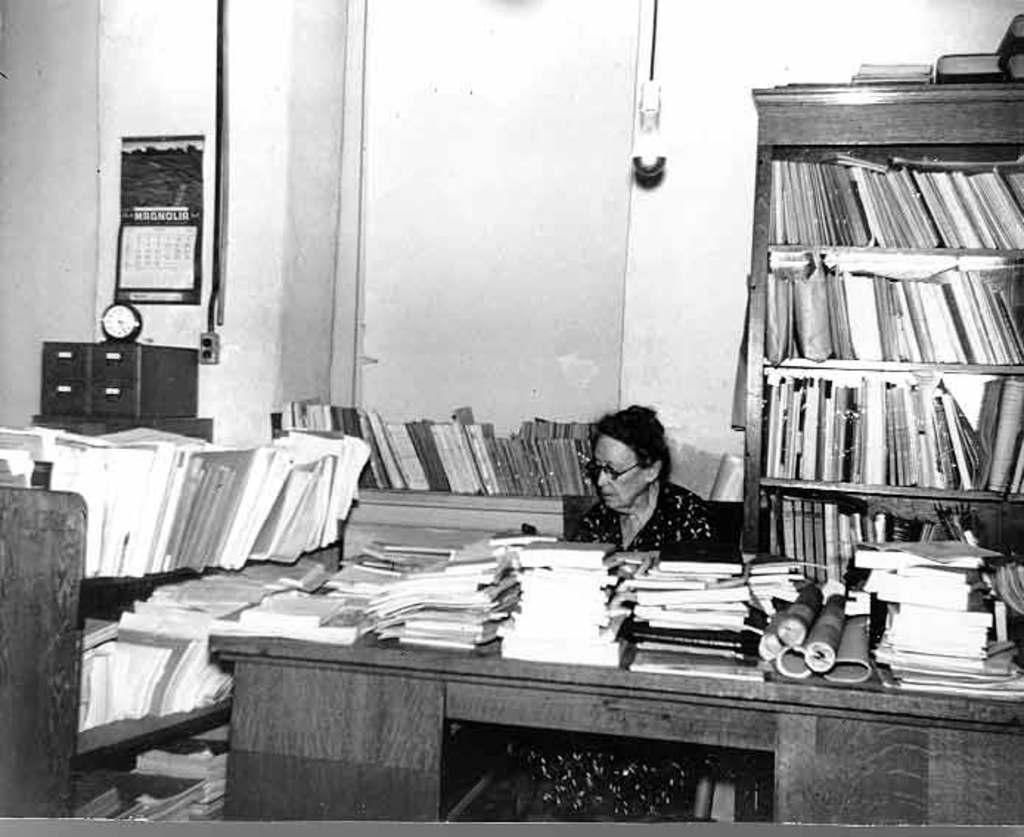Please provide a concise description of this image. This picture is clicked inside the room. In the foreground we can see a table on the top of which books and some objects are placed and we can see a person sitting on the chair. On the left we can see a rack containing many books. In the background we can see the wall, an object which seems to be the light and we can see a calendar like object hanging on the wall and we can see a clock, boxes and a cabinet containing books and we can see the books and some objects in the background. 